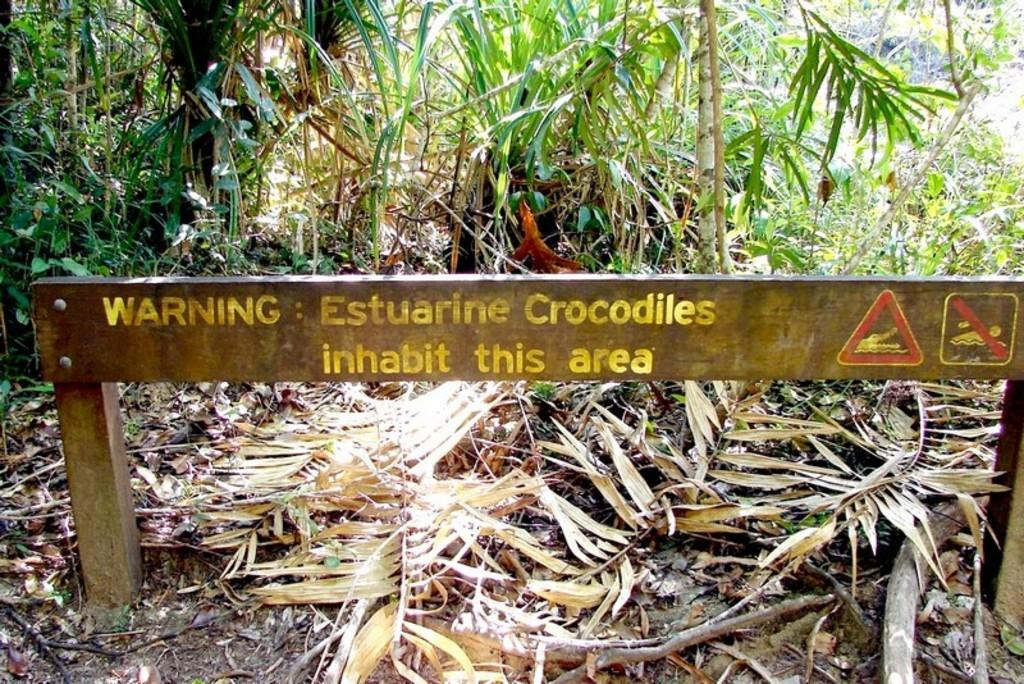What is the main structure in the image? There is a board attached to poles in the image. What can be seen on the ground in the image? Dried leaves are present on the land in the image. What type of vegetation is visible in the background of the image? There are plants with leaves in the background of the image. What type of lunch is being served in the image? There is no lunch present in the image; it features a board attached to poles, dried leaves on the ground, and plants with leaves in the background. Can you see a cat in the image? There is no cat present in the image. 